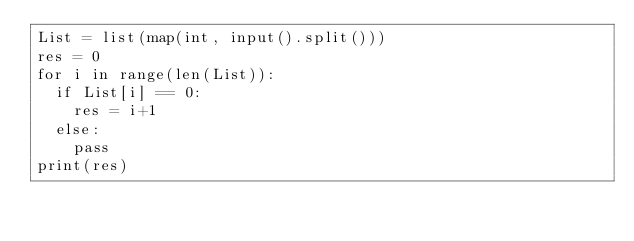<code> <loc_0><loc_0><loc_500><loc_500><_Python_>List = list(map(int, input().split()))
res = 0
for i in range(len(List)):
  if List[i] == 0:
    res = i+1
  else:
    pass
print(res)</code> 